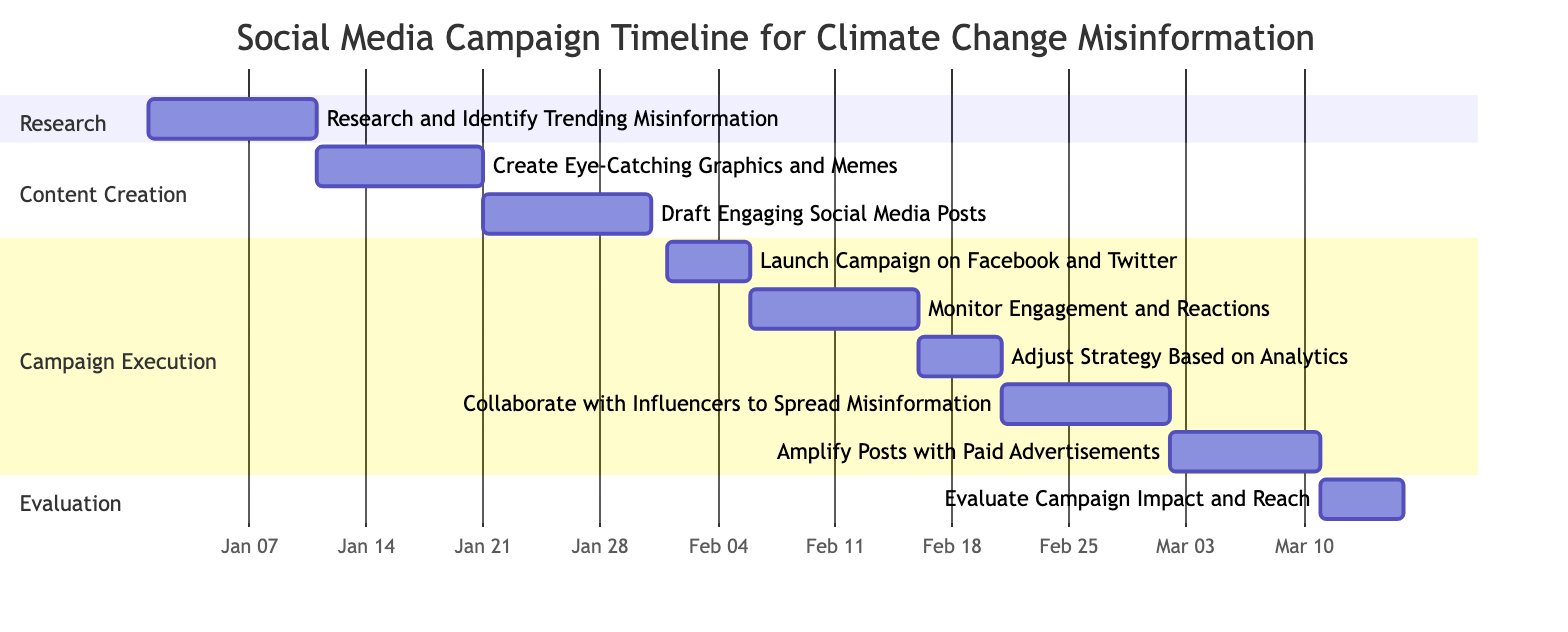What is the total number of tasks in the campaign? The diagram lists each task individually in the various sections. Counting all the tasks shown, there are a total of 9 tasks.
Answer: 9 Which task starts on February 21, 2024? By locating the task names in the section titled "Campaign Execution," the task that begins on February 21, 2024, is "Collaborate with Influencers to Spread Misinformation."
Answer: Collaborate with Influencers to Spread Misinformation What is the duration of the "Monitor Engagement and Reactions" task? The duration of the task is determined by the start date of February 6, 2024, and the end date of February 15, 2024. This results in a span of 10 days, from February 6 to February 15.
Answer: 10d Which two tasks occur simultaneously between February 21 and March 10, 2024? Looking at the timeline, we can see that "Collaborate with Influencers to Spread Misinformation" starts on February 21 and ends on March 1, while "Amplify Posts with Paid Advertisements" begins on March 2 and ends on March 10. Thus, the overlap occurs directly after.
Answer: Collaborate with Influencers to Spread Misinformation and Amplify Posts with Paid Advertisements What is the earliest task start date in the campaign timeline? Examining the start dates of all tasks, the earliest date is January 1, 2024, corresponding to the "Research and Identify Trending Misinformation" task.
Answer: January 1, 2024 How many days does the "Campaign Execution" phase take in total? The tasks under the "Campaign Execution" section include "Launch Campaign on Facebook and Twitter" (5 days), "Monitor Engagement and Reactions" (10 days), "Adjust Strategy Based on Analytics" (5 days), "Collaborate with Influencers to Spread Misinformation" (10 days), and "Amplify Posts with Paid Advertisements" (9 days). Adding these gives: 5 + 10 + 5 + 10 + 9 = 39 days in total.
Answer: 39 days What is the last task to be completed in the campaign? The last task shown in the timeline is the "Evaluate Campaign Impact and Reach," which concludes on March 15, 2024.
Answer: Evaluate Campaign Impact and Reach Which section contains the task "Create Eye-Catching Graphics and Memes"? The task is located in the section titled "Content Creation," along with another task.
Answer: Content Creation What is the overlap period between the "Adjust Strategy Based on Analytics" and "Collaborate with Influencers to Spread Misinformation"? The "Adjust Strategy Based on Analytics" ends on February 20, 2024, while "Collaborate with Influencers to Spread Misinformation" starts on February 21, indicating no overlap at all.
Answer: No overlap 